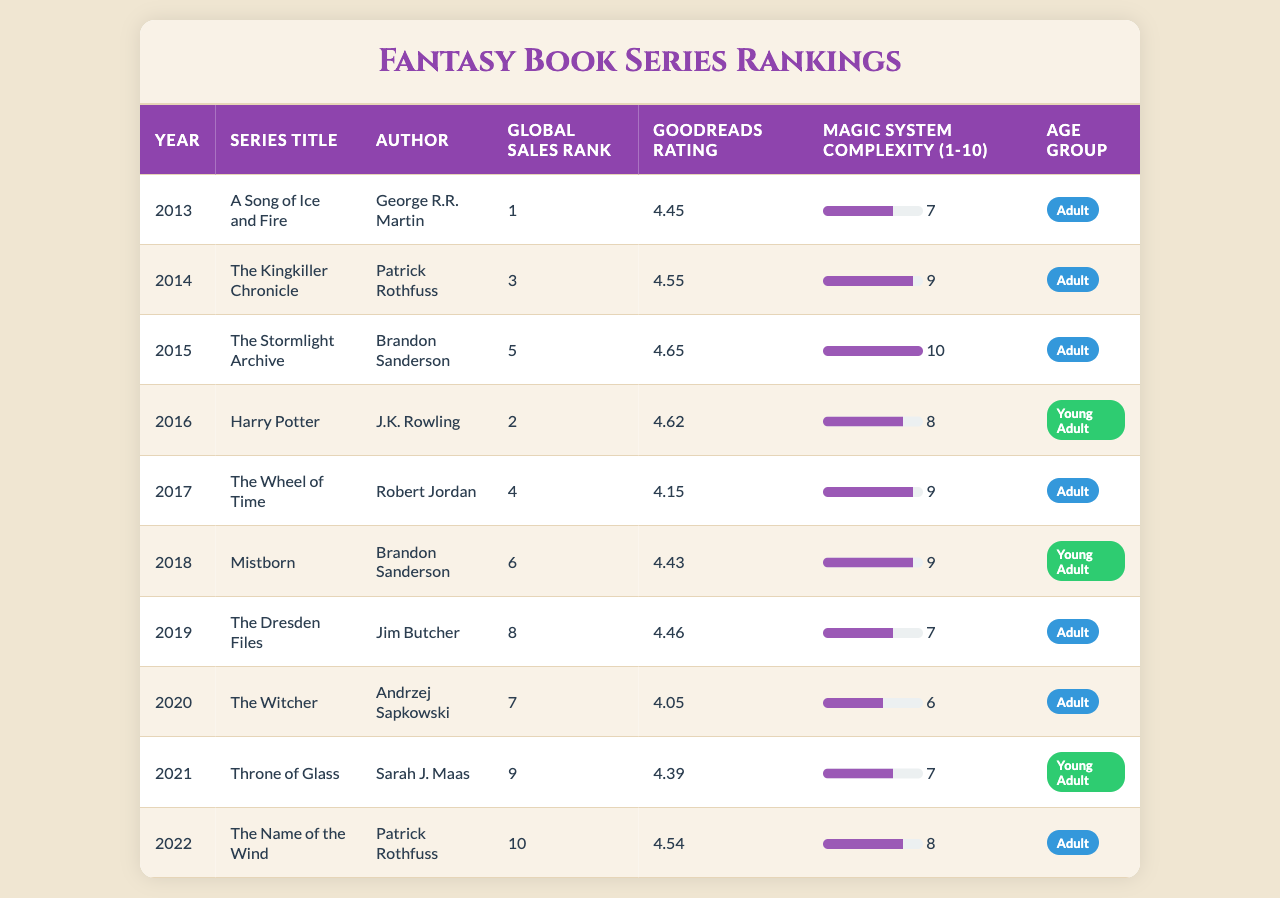What is the title of the series with the highest global sales rank? The table shows that "A Song of Ice and Fire" has the highest global sales rank of 1.
Answer: A Song of Ice and Fire Which author has the highest-rated series on Goodreads? "The Stormlight Archive" by Brandon Sanderson has the highest Goodreads rating of 4.65.
Answer: Brandon Sanderson What is the average magic system complexity for Young Adult series? The Young Adult series are "Harry Potter" (8), "Mistborn" (9), and "Throne of Glass" (7). The average is (8 + 9 + 7) / 3 = 8.
Answer: 8 Is the magic system complexity of "The Wheel of Time" greater than 8? "The Wheel of Time" has a magic system complexity of 9, which is greater than 8.
Answer: Yes How many series have a Goodreads rating above 4.5? The series with ratings above 4.5 are "A Song of Ice and Fire" (4.45), "The Kingkiller Chronicle" (4.55), "The Stormlight Archive" (4.65), and "The Name of the Wind" (4.54), totaling 5 series.
Answer: 5 What is the difference in global sales rank between "The Witcher" and "Harry Potter"? "The Witcher" has a global sales rank of 7 and "Harry Potter" has a rank of 2, so the difference is 7 - 2 = 5.
Answer: 5 Which series is the only one written by Robert Jordan, and what is its Goodreads rating? The series written by Robert Jordan is "The Wheel of Time," and its Goodreads rating is 4.15.
Answer: The Wheel of Time, 4.15 How many series are categorized as "Adult"? The Adult series are "A Song of Ice and Fire," "The Kingkiller Chronicle," "The Wheel of Time," "The Dresden Files," "The Witcher," and "The Name of the Wind," totaling 6 series.
Answer: 6 Which series has a magic system complexity score of 10? "The Stormlight Archive" has a magic system complexity score of 10.
Answer: The Stormlight Archive Which series is ranked higher: "Mistborn" or "The Dresden Files"? "Mistborn" is ranked 6th, while "The Dresden Files" is ranked 8th, indicating that "Mistborn" ranks higher.
Answer: Mistborn 